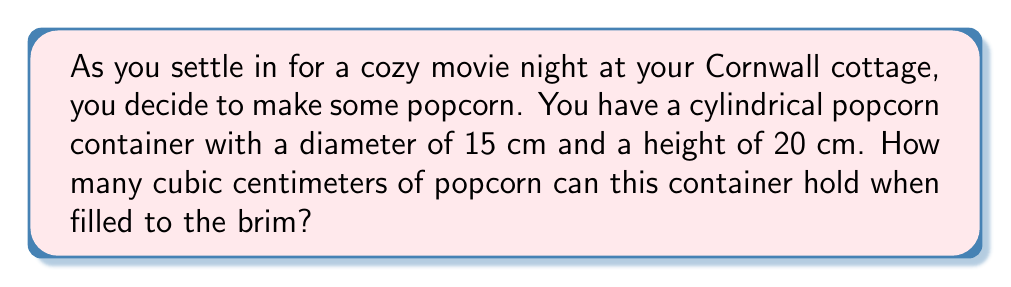Teach me how to tackle this problem. To find the volume of a cylindrical popcorn container, we need to use the formula for the volume of a cylinder:

$$V = \pi r^2 h$$

Where:
$V$ = volume
$r$ = radius of the base
$h$ = height of the cylinder

Let's solve this step-by-step:

1. We're given the diameter of 15 cm, so we need to find the radius:
   $r = \frac{diameter}{2} = \frac{15}{2} = 7.5$ cm

2. We're given the height of 20 cm.

3. Now let's substitute these values into our formula:
   $$V = \pi (7.5\text{ cm})^2 (20\text{ cm})$$

4. Simplify:
   $$V = \pi (56.25\text{ cm}^2) (20\text{ cm})$$
   $$V = 1125\pi\text{ cm}^3$$

5. Calculate the final value (rounded to the nearest whole number):
   $$V \approx 3534\text{ cm}^3$$

Therefore, the cylindrical popcorn container can hold approximately 3534 cubic centimeters of popcorn.
Answer: $3534\text{ cm}^3$ 